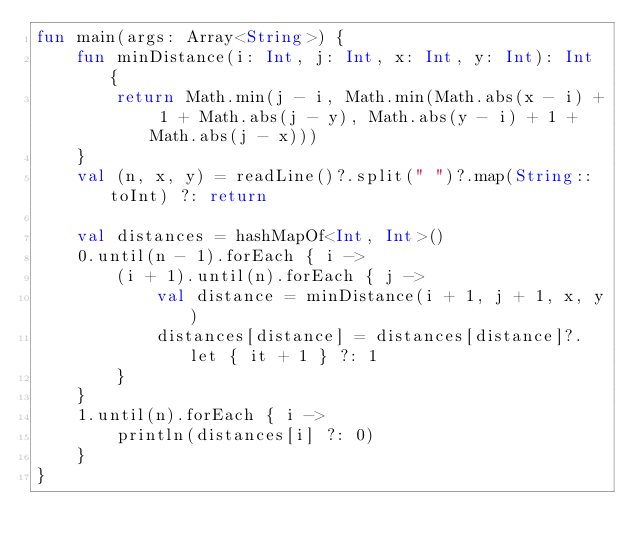<code> <loc_0><loc_0><loc_500><loc_500><_Kotlin_>fun main(args: Array<String>) {
    fun minDistance(i: Int, j: Int, x: Int, y: Int): Int {
        return Math.min(j - i, Math.min(Math.abs(x - i) + 1 + Math.abs(j - y), Math.abs(y - i) + 1 + Math.abs(j - x)))
    }
    val (n, x, y) = readLine()?.split(" ")?.map(String::toInt) ?: return

    val distances = hashMapOf<Int, Int>()
    0.until(n - 1).forEach { i ->
        (i + 1).until(n).forEach { j ->
            val distance = minDistance(i + 1, j + 1, x, y)
            distances[distance] = distances[distance]?.let { it + 1 } ?: 1
        }
    }
    1.until(n).forEach { i ->
        println(distances[i] ?: 0)
    }
}</code> 